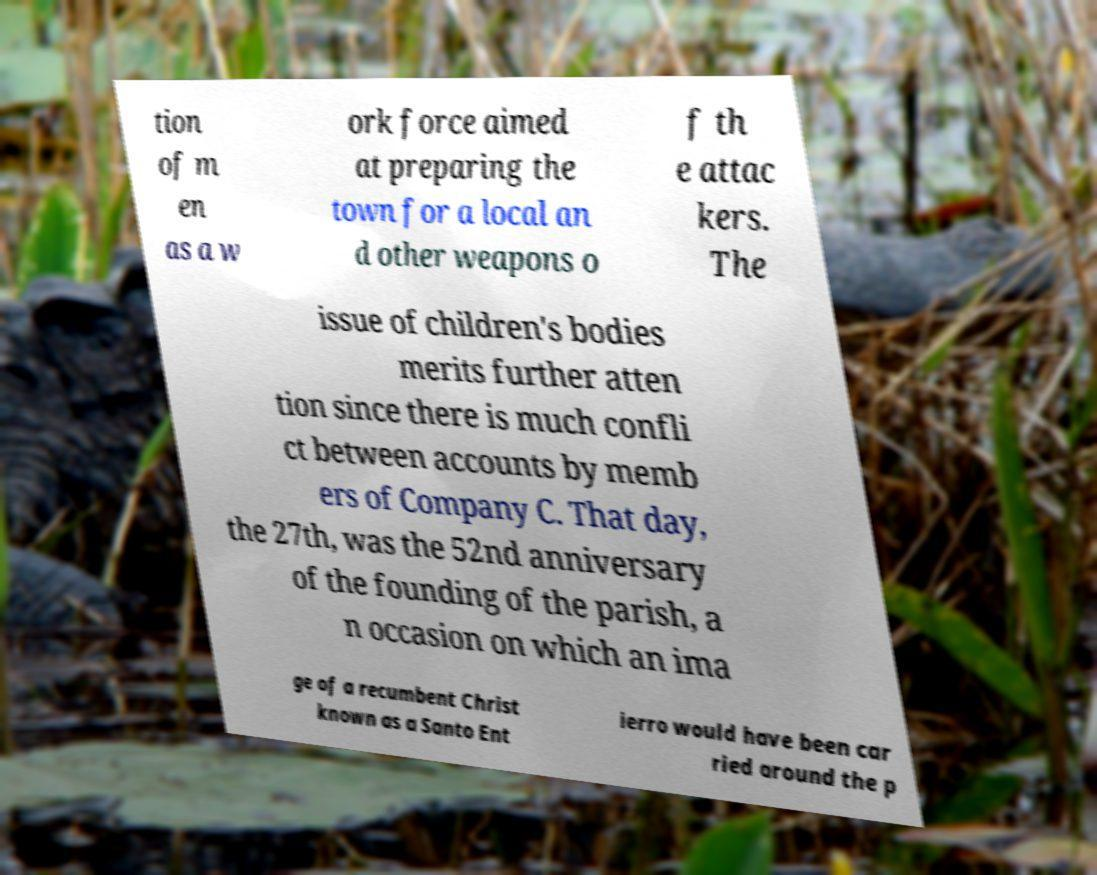Please read and relay the text visible in this image. What does it say? tion of m en as a w ork force aimed at preparing the town for a local an d other weapons o f th e attac kers. The issue of children's bodies merits further atten tion since there is much confli ct between accounts by memb ers of Company C. That day, the 27th, was the 52nd anniversary of the founding of the parish, a n occasion on which an ima ge of a recumbent Christ known as a Santo Ent ierro would have been car ried around the p 